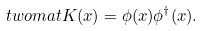Convert formula to latex. <formula><loc_0><loc_0><loc_500><loc_500>\ t w o m a t { K } ( x ) = \phi ( x ) \phi ^ { \dagger } ( x ) .</formula> 